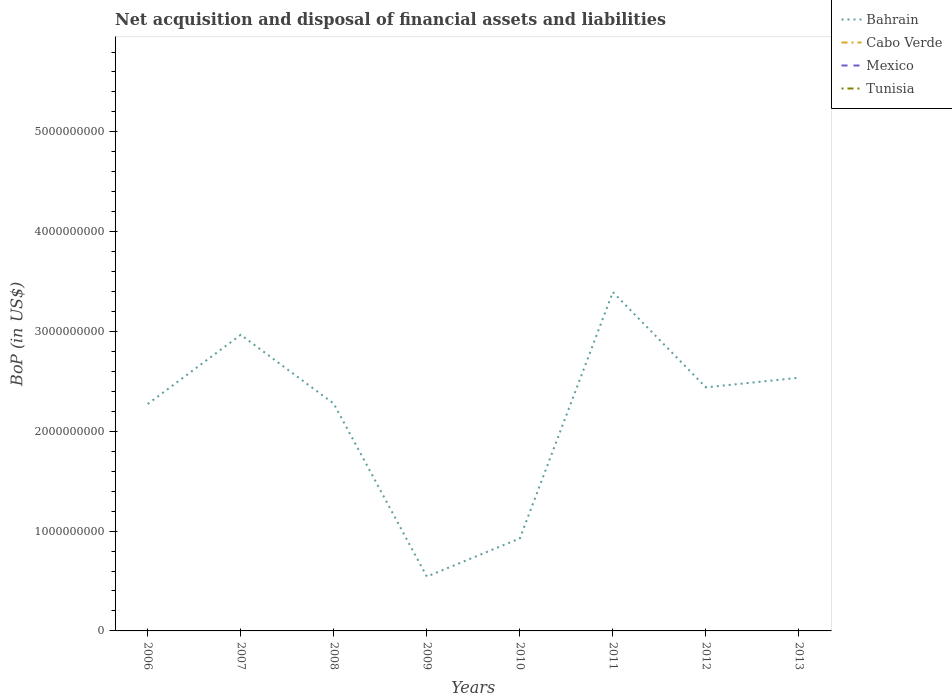Does the line corresponding to Cabo Verde intersect with the line corresponding to Mexico?
Ensure brevity in your answer.  No. Is the number of lines equal to the number of legend labels?
Ensure brevity in your answer.  No. Across all years, what is the maximum Balance of Payments in Mexico?
Your answer should be compact. 0. What is the total Balance of Payments in Bahrain in the graph?
Keep it short and to the point. 1.73e+09. What is the difference between the highest and the lowest Balance of Payments in Cabo Verde?
Provide a succinct answer. 0. Is the Balance of Payments in Bahrain strictly greater than the Balance of Payments in Tunisia over the years?
Your answer should be compact. No. How many lines are there?
Provide a short and direct response. 1. What is the difference between two consecutive major ticks on the Y-axis?
Your answer should be very brief. 1.00e+09. Are the values on the major ticks of Y-axis written in scientific E-notation?
Your response must be concise. No. Does the graph contain any zero values?
Your answer should be very brief. Yes. Does the graph contain grids?
Provide a short and direct response. No. How many legend labels are there?
Offer a very short reply. 4. How are the legend labels stacked?
Provide a succinct answer. Vertical. What is the title of the graph?
Offer a very short reply. Net acquisition and disposal of financial assets and liabilities. Does "Macao" appear as one of the legend labels in the graph?
Give a very brief answer. No. What is the label or title of the Y-axis?
Your answer should be very brief. BoP (in US$). What is the BoP (in US$) of Bahrain in 2006?
Keep it short and to the point. 2.27e+09. What is the BoP (in US$) of Cabo Verde in 2006?
Your response must be concise. 0. What is the BoP (in US$) of Bahrain in 2007?
Your response must be concise. 2.97e+09. What is the BoP (in US$) of Cabo Verde in 2007?
Make the answer very short. 0. What is the BoP (in US$) of Bahrain in 2008?
Keep it short and to the point. 2.28e+09. What is the BoP (in US$) in Mexico in 2008?
Give a very brief answer. 0. What is the BoP (in US$) in Bahrain in 2009?
Your answer should be very brief. 5.44e+08. What is the BoP (in US$) of Cabo Verde in 2009?
Your answer should be very brief. 0. What is the BoP (in US$) of Mexico in 2009?
Keep it short and to the point. 0. What is the BoP (in US$) in Tunisia in 2009?
Offer a terse response. 0. What is the BoP (in US$) of Bahrain in 2010?
Provide a short and direct response. 9.27e+08. What is the BoP (in US$) of Cabo Verde in 2010?
Give a very brief answer. 0. What is the BoP (in US$) of Tunisia in 2010?
Offer a very short reply. 0. What is the BoP (in US$) in Bahrain in 2011?
Offer a very short reply. 3.39e+09. What is the BoP (in US$) of Cabo Verde in 2011?
Your response must be concise. 0. What is the BoP (in US$) of Mexico in 2011?
Your answer should be very brief. 0. What is the BoP (in US$) in Tunisia in 2011?
Give a very brief answer. 0. What is the BoP (in US$) of Bahrain in 2012?
Your answer should be very brief. 2.44e+09. What is the BoP (in US$) of Cabo Verde in 2012?
Your answer should be compact. 0. What is the BoP (in US$) of Tunisia in 2012?
Your answer should be compact. 0. What is the BoP (in US$) of Bahrain in 2013?
Your answer should be very brief. 2.54e+09. What is the BoP (in US$) of Tunisia in 2013?
Make the answer very short. 0. Across all years, what is the maximum BoP (in US$) of Bahrain?
Your response must be concise. 3.39e+09. Across all years, what is the minimum BoP (in US$) of Bahrain?
Your response must be concise. 5.44e+08. What is the total BoP (in US$) of Bahrain in the graph?
Offer a very short reply. 1.74e+1. What is the total BoP (in US$) in Cabo Verde in the graph?
Give a very brief answer. 0. What is the difference between the BoP (in US$) in Bahrain in 2006 and that in 2007?
Offer a terse response. -6.93e+08. What is the difference between the BoP (in US$) in Bahrain in 2006 and that in 2008?
Your answer should be very brief. -3.25e+06. What is the difference between the BoP (in US$) in Bahrain in 2006 and that in 2009?
Give a very brief answer. 1.73e+09. What is the difference between the BoP (in US$) in Bahrain in 2006 and that in 2010?
Your answer should be very brief. 1.35e+09. What is the difference between the BoP (in US$) in Bahrain in 2006 and that in 2011?
Provide a succinct answer. -1.12e+09. What is the difference between the BoP (in US$) in Bahrain in 2006 and that in 2012?
Keep it short and to the point. -1.67e+08. What is the difference between the BoP (in US$) in Bahrain in 2006 and that in 2013?
Give a very brief answer. -2.63e+08. What is the difference between the BoP (in US$) of Bahrain in 2007 and that in 2008?
Provide a short and direct response. 6.90e+08. What is the difference between the BoP (in US$) of Bahrain in 2007 and that in 2009?
Provide a succinct answer. 2.42e+09. What is the difference between the BoP (in US$) in Bahrain in 2007 and that in 2010?
Make the answer very short. 2.04e+09. What is the difference between the BoP (in US$) in Bahrain in 2007 and that in 2011?
Give a very brief answer. -4.28e+08. What is the difference between the BoP (in US$) of Bahrain in 2007 and that in 2012?
Your answer should be compact. 5.27e+08. What is the difference between the BoP (in US$) of Bahrain in 2007 and that in 2013?
Give a very brief answer. 4.30e+08. What is the difference between the BoP (in US$) in Bahrain in 2008 and that in 2009?
Your answer should be compact. 1.73e+09. What is the difference between the BoP (in US$) in Bahrain in 2008 and that in 2010?
Make the answer very short. 1.35e+09. What is the difference between the BoP (in US$) in Bahrain in 2008 and that in 2011?
Your response must be concise. -1.12e+09. What is the difference between the BoP (in US$) in Bahrain in 2008 and that in 2012?
Provide a succinct answer. -1.64e+08. What is the difference between the BoP (in US$) of Bahrain in 2008 and that in 2013?
Your answer should be very brief. -2.60e+08. What is the difference between the BoP (in US$) of Bahrain in 2009 and that in 2010?
Offer a terse response. -3.83e+08. What is the difference between the BoP (in US$) of Bahrain in 2009 and that in 2011?
Provide a short and direct response. -2.85e+09. What is the difference between the BoP (in US$) of Bahrain in 2009 and that in 2012?
Keep it short and to the point. -1.90e+09. What is the difference between the BoP (in US$) of Bahrain in 2009 and that in 2013?
Ensure brevity in your answer.  -1.99e+09. What is the difference between the BoP (in US$) in Bahrain in 2010 and that in 2011?
Make the answer very short. -2.47e+09. What is the difference between the BoP (in US$) in Bahrain in 2010 and that in 2012?
Keep it short and to the point. -1.51e+09. What is the difference between the BoP (in US$) of Bahrain in 2010 and that in 2013?
Keep it short and to the point. -1.61e+09. What is the difference between the BoP (in US$) of Bahrain in 2011 and that in 2012?
Provide a short and direct response. 9.55e+08. What is the difference between the BoP (in US$) in Bahrain in 2011 and that in 2013?
Give a very brief answer. 8.58e+08. What is the difference between the BoP (in US$) of Bahrain in 2012 and that in 2013?
Your response must be concise. -9.65e+07. What is the average BoP (in US$) of Bahrain per year?
Your answer should be compact. 2.17e+09. What is the average BoP (in US$) of Cabo Verde per year?
Provide a short and direct response. 0. What is the average BoP (in US$) in Tunisia per year?
Give a very brief answer. 0. What is the ratio of the BoP (in US$) in Bahrain in 2006 to that in 2007?
Keep it short and to the point. 0.77. What is the ratio of the BoP (in US$) in Bahrain in 2006 to that in 2008?
Provide a succinct answer. 1. What is the ratio of the BoP (in US$) in Bahrain in 2006 to that in 2009?
Provide a short and direct response. 4.18. What is the ratio of the BoP (in US$) in Bahrain in 2006 to that in 2010?
Your answer should be very brief. 2.45. What is the ratio of the BoP (in US$) of Bahrain in 2006 to that in 2011?
Keep it short and to the point. 0.67. What is the ratio of the BoP (in US$) in Bahrain in 2006 to that in 2012?
Your answer should be very brief. 0.93. What is the ratio of the BoP (in US$) of Bahrain in 2006 to that in 2013?
Offer a very short reply. 0.9. What is the ratio of the BoP (in US$) of Bahrain in 2007 to that in 2008?
Your response must be concise. 1.3. What is the ratio of the BoP (in US$) of Bahrain in 2007 to that in 2009?
Keep it short and to the point. 5.45. What is the ratio of the BoP (in US$) of Bahrain in 2007 to that in 2010?
Provide a short and direct response. 3.2. What is the ratio of the BoP (in US$) of Bahrain in 2007 to that in 2011?
Make the answer very short. 0.87. What is the ratio of the BoP (in US$) of Bahrain in 2007 to that in 2012?
Provide a short and direct response. 1.22. What is the ratio of the BoP (in US$) in Bahrain in 2007 to that in 2013?
Make the answer very short. 1.17. What is the ratio of the BoP (in US$) in Bahrain in 2008 to that in 2009?
Keep it short and to the point. 4.18. What is the ratio of the BoP (in US$) in Bahrain in 2008 to that in 2010?
Your response must be concise. 2.46. What is the ratio of the BoP (in US$) in Bahrain in 2008 to that in 2011?
Give a very brief answer. 0.67. What is the ratio of the BoP (in US$) of Bahrain in 2008 to that in 2012?
Provide a succinct answer. 0.93. What is the ratio of the BoP (in US$) in Bahrain in 2008 to that in 2013?
Ensure brevity in your answer.  0.9. What is the ratio of the BoP (in US$) in Bahrain in 2009 to that in 2010?
Your answer should be very brief. 0.59. What is the ratio of the BoP (in US$) of Bahrain in 2009 to that in 2011?
Your response must be concise. 0.16. What is the ratio of the BoP (in US$) in Bahrain in 2009 to that in 2012?
Provide a succinct answer. 0.22. What is the ratio of the BoP (in US$) in Bahrain in 2009 to that in 2013?
Provide a short and direct response. 0.21. What is the ratio of the BoP (in US$) in Bahrain in 2010 to that in 2011?
Offer a very short reply. 0.27. What is the ratio of the BoP (in US$) of Bahrain in 2010 to that in 2012?
Provide a short and direct response. 0.38. What is the ratio of the BoP (in US$) of Bahrain in 2010 to that in 2013?
Provide a succinct answer. 0.37. What is the ratio of the BoP (in US$) in Bahrain in 2011 to that in 2012?
Your response must be concise. 1.39. What is the ratio of the BoP (in US$) of Bahrain in 2011 to that in 2013?
Offer a very short reply. 1.34. What is the ratio of the BoP (in US$) in Bahrain in 2012 to that in 2013?
Make the answer very short. 0.96. What is the difference between the highest and the second highest BoP (in US$) of Bahrain?
Your answer should be very brief. 4.28e+08. What is the difference between the highest and the lowest BoP (in US$) in Bahrain?
Your response must be concise. 2.85e+09. 